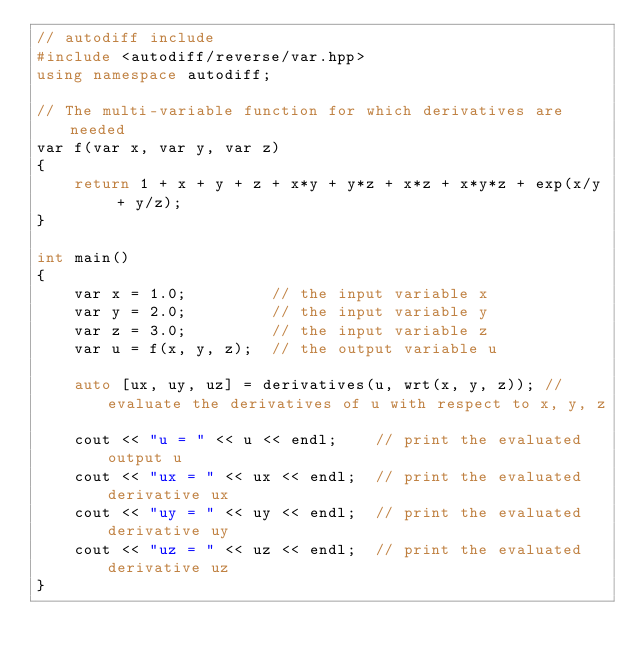<code> <loc_0><loc_0><loc_500><loc_500><_C++_>// autodiff include
#include <autodiff/reverse/var.hpp>
using namespace autodiff;

// The multi-variable function for which derivatives are needed
var f(var x, var y, var z)
{
    return 1 + x + y + z + x*y + y*z + x*z + x*y*z + exp(x/y + y/z);
}

int main()
{
    var x = 1.0;         // the input variable x
    var y = 2.0;         // the input variable y
    var z = 3.0;         // the input variable z
    var u = f(x, y, z);  // the output variable u

    auto [ux, uy, uz] = derivatives(u, wrt(x, y, z)); // evaluate the derivatives of u with respect to x, y, z

    cout << "u = " << u << endl;    // print the evaluated output u
    cout << "ux = " << ux << endl;  // print the evaluated derivative ux
    cout << "uy = " << uy << endl;  // print the evaluated derivative uy
    cout << "uz = " << uz << endl;  // print the evaluated derivative uz
}
</code> 